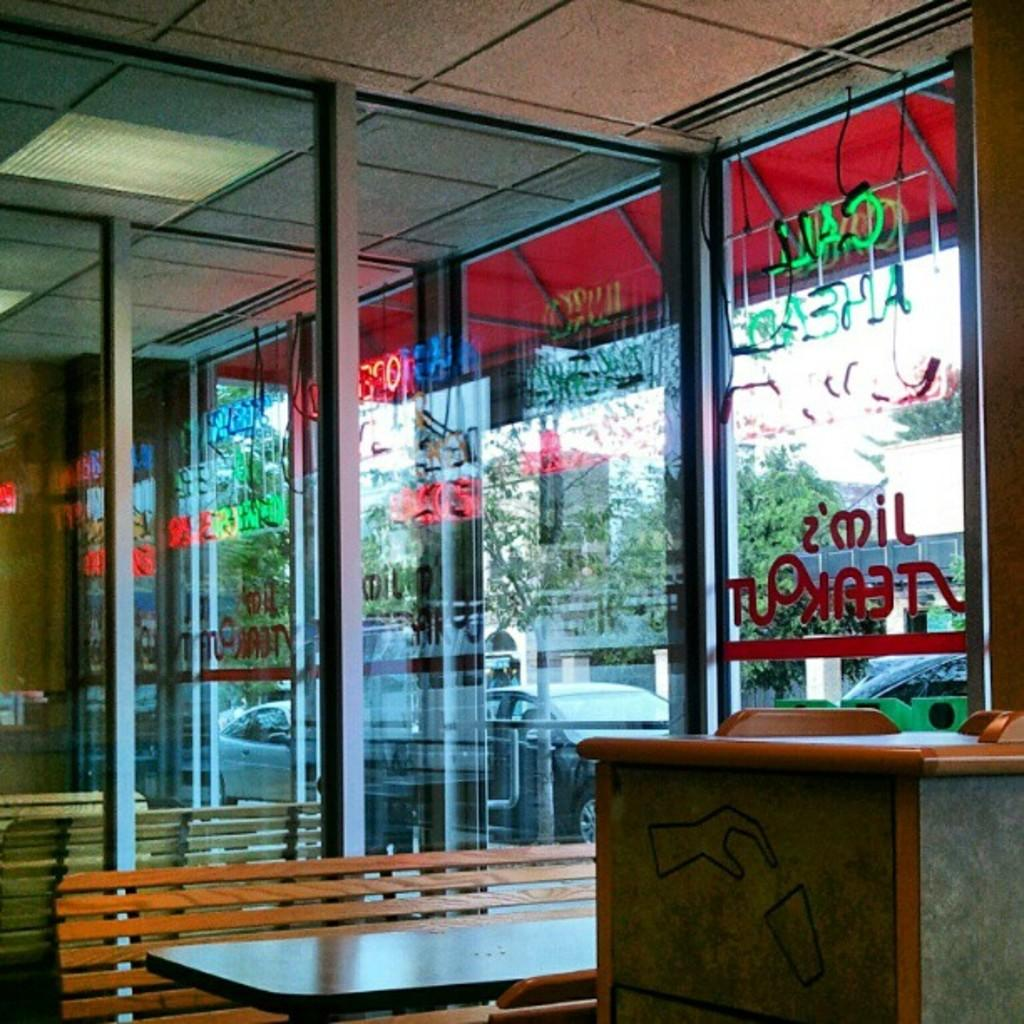What type of furniture is present in the image? There is a bench and a table in the image. What object is used for waste disposal in the image? There is a dustbin in the image. What can be seen on the glass object in the image? There is text on a glass object in the image. What can be seen through the glass object in the image? Cars, trees, and a building are visible through the glass. Can you tell me the price of the haircut on the receipt in the image? There is no haircut or receipt present in the image. What type of zipper is visible on the bench in the image? There is no zipper present on the bench in the image. 